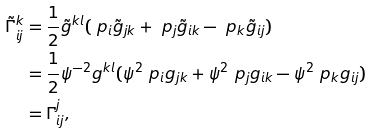Convert formula to latex. <formula><loc_0><loc_0><loc_500><loc_500>\tilde { \Gamma } _ { i j } ^ { k } & = \frac { 1 } { 2 } \tilde { g } ^ { k l } ( \ p _ { i } \tilde { g } _ { j k } + \ p _ { j } \tilde { g } _ { i k } - \ p _ { k } \tilde { g } _ { i j } ) \\ & = \frac { 1 } { 2 } \psi ^ { - 2 } g ^ { k l } ( \psi ^ { 2 } \ p _ { i } g _ { j k } + \psi ^ { 2 } \ p _ { j } g _ { i k } - \psi ^ { 2 } \ p _ { k } g _ { i j } ) \\ & = \Gamma _ { i j } ^ { j } ,</formula> 